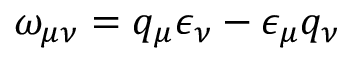Convert formula to latex. <formula><loc_0><loc_0><loc_500><loc_500>\omega _ { \mu \nu } = q _ { \mu } \epsilon _ { \nu } - \epsilon _ { \mu } q _ { \nu }</formula> 